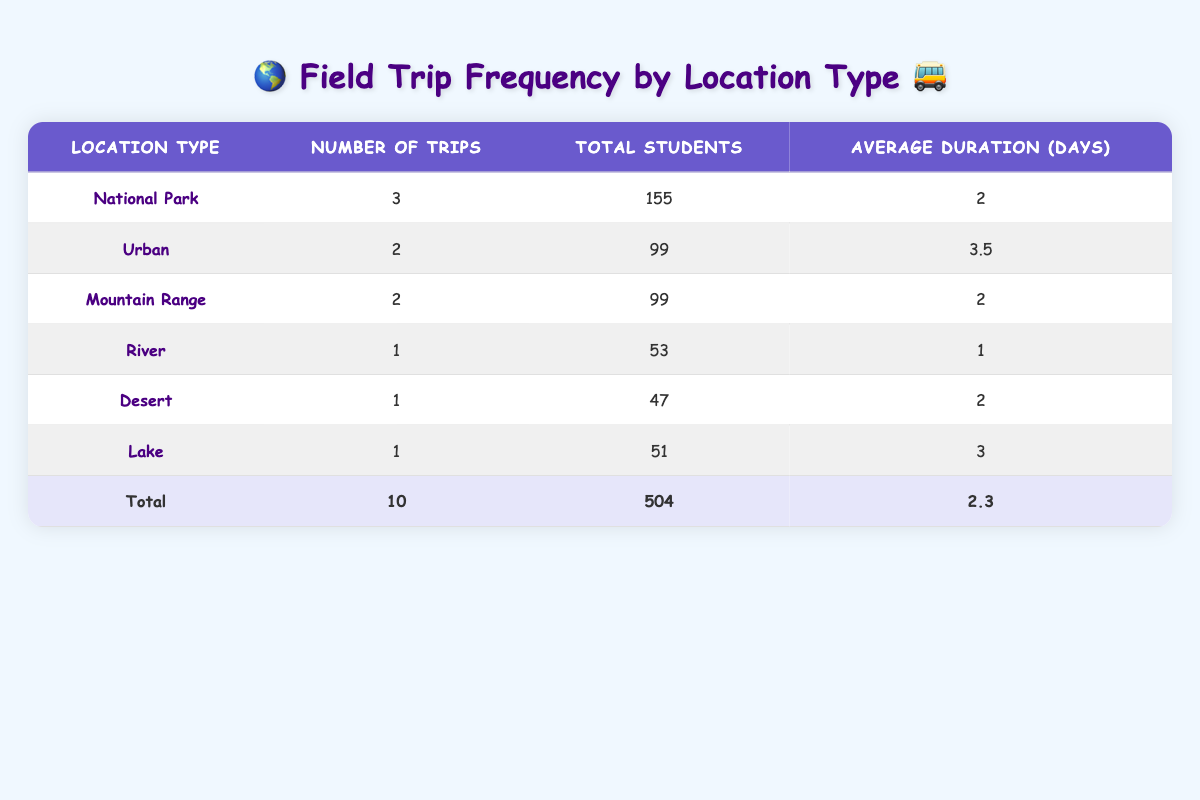What is the total number of trips to National Parks? From the table, the total number of trips to National Parks is found under the "Number of Trips" column corresponding to the "National Park" type, which shows a value of 3.
Answer: 3 Which location type had the most students attending field trips? By examining the "Total Students" column, the highest value is for "National Park," with a total of 155 students.
Answer: National Park What is the average duration of trips to Urban locations? There are two trips designated as Urban. Their durations are 4 days (New York City) and 3 days (San Francisco). To find the average, add these days: 4 + 3 = 7, and divide by 2, giving 7/2 = 3.5 days.
Answer: 3.5 Did any trips to the Desert involve more students than any trips to the River? The Desert trip had 47 students while the River trip had 53 students. Since 47 is less than 53, the statement is false.
Answer: No What is the total number of students across all field trips? To find the total students, sum the "Total Students" column: 155 + 99 + 99 + 53 + 47 + 51 = 504. Since this matches the total row, it confirms the number.
Answer: 504 How many location types have had exactly 1 trip? There are three location types with exactly 1 trip: River, Desert, and Lake, as noted in the "Number of Trips" column.
Answer: 3 Which location type had the shortest average duration of trips, and what is that duration? The type with the shortest average duration is "River," which has a duration of 1 day, as indicated in the "Average Duration (Days)" column.
Answer: River, 1 day If we add the number of trips for Mountain Ranges and Urban locations, what total do we get? For Mountain Ranges, there are 2 trips and for Urban, there are also 2 trips. Adding these together gives 2 + 2 = 4 trips in total.
Answer: 4 